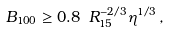Convert formula to latex. <formula><loc_0><loc_0><loc_500><loc_500>B _ { 1 0 0 } \geq 0 . 8 \ R _ { 1 5 } ^ { - 2 / 3 } \eta ^ { 1 / 3 } \, ,</formula> 